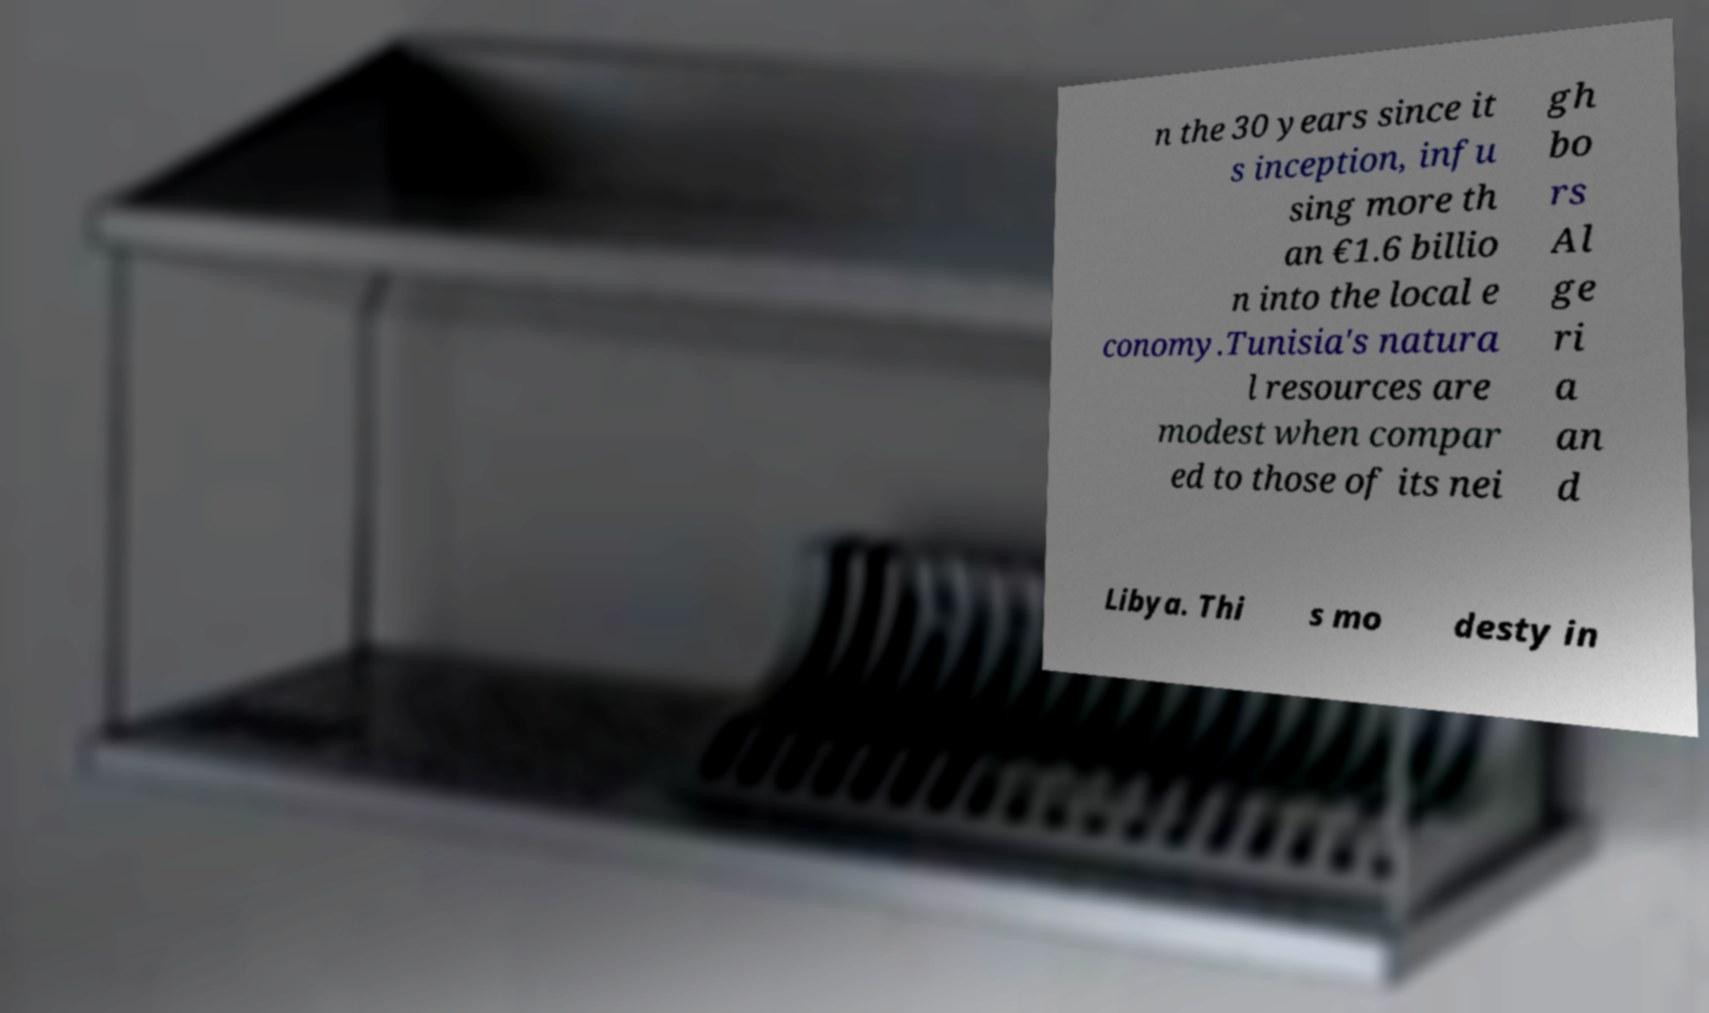Could you extract and type out the text from this image? n the 30 years since it s inception, infu sing more th an €1.6 billio n into the local e conomy.Tunisia's natura l resources are modest when compar ed to those of its nei gh bo rs Al ge ri a an d Libya. Thi s mo desty in 